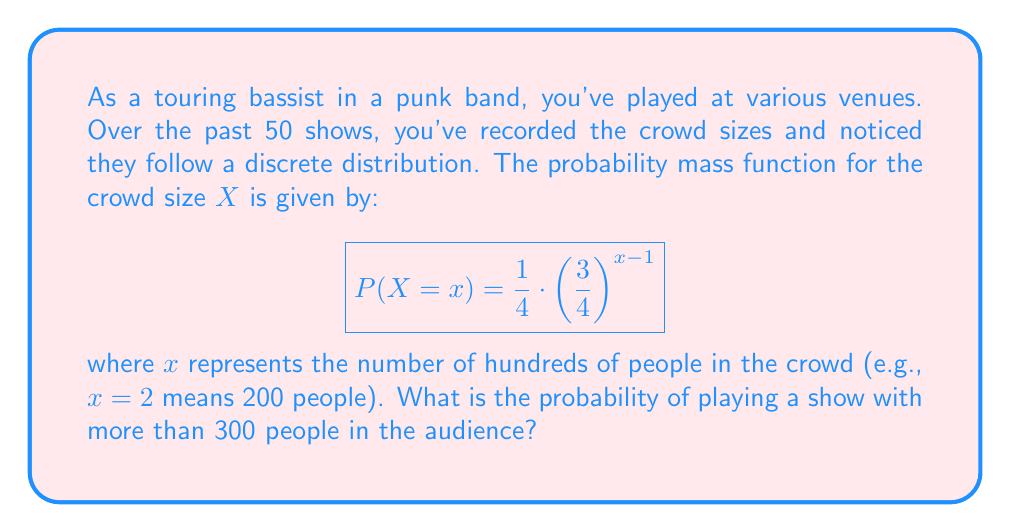Could you help me with this problem? Let's approach this step-by-step:

1) We need to find $P(X > 3)$, as $X = 3$ represents 300 people.

2) We can calculate this as:
   $P(X > 3) = 1 - P(X \leq 3)$

3) $P(X \leq 3) = P(X = 1) + P(X = 2) + P(X = 3)$

4) Let's calculate each term:

   $P(X = 1) = \frac{1}{4} \cdot \left(\frac{3}{4}\right)^{1-1} = \frac{1}{4}$

   $P(X = 2) = \frac{1}{4} \cdot \left(\frac{3}{4}\right)^{2-1} = \frac{1}{4} \cdot \frac{3}{4} = \frac{3}{16}$

   $P(X = 3) = \frac{1}{4} \cdot \left(\frac{3}{4}\right)^{3-1} = \frac{1}{4} \cdot \left(\frac{3}{4}\right)^2 = \frac{9}{64}$

5) Sum these probabilities:
   $P(X \leq 3) = \frac{1}{4} + \frac{3}{16} + \frac{9}{64} = \frac{16}{64} + \frac{12}{64} + \frac{9}{64} = \frac{37}{64}$

6) Therefore:
   $P(X > 3) = 1 - P(X \leq 3) = 1 - \frac{37}{64} = \frac{27}{64}$
Answer: $\frac{27}{64}$ 